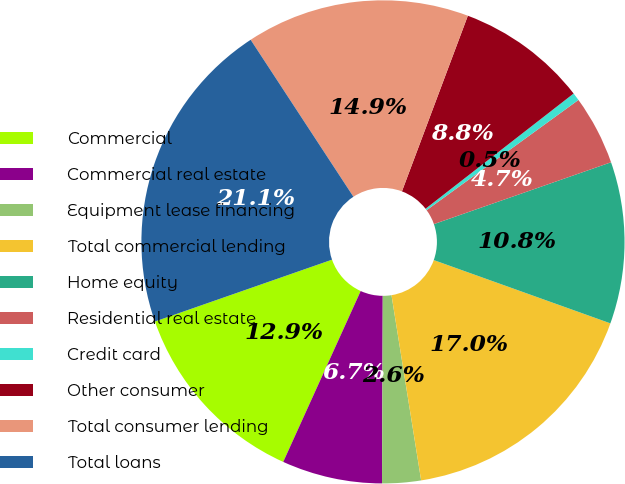<chart> <loc_0><loc_0><loc_500><loc_500><pie_chart><fcel>Commercial<fcel>Commercial real estate<fcel>Equipment lease financing<fcel>Total commercial lending<fcel>Home equity<fcel>Residential real estate<fcel>Credit card<fcel>Other consumer<fcel>Total consumer lending<fcel>Total loans<nl><fcel>12.88%<fcel>6.71%<fcel>2.59%<fcel>17.0%<fcel>10.82%<fcel>4.65%<fcel>0.53%<fcel>8.76%<fcel>14.94%<fcel>21.12%<nl></chart> 